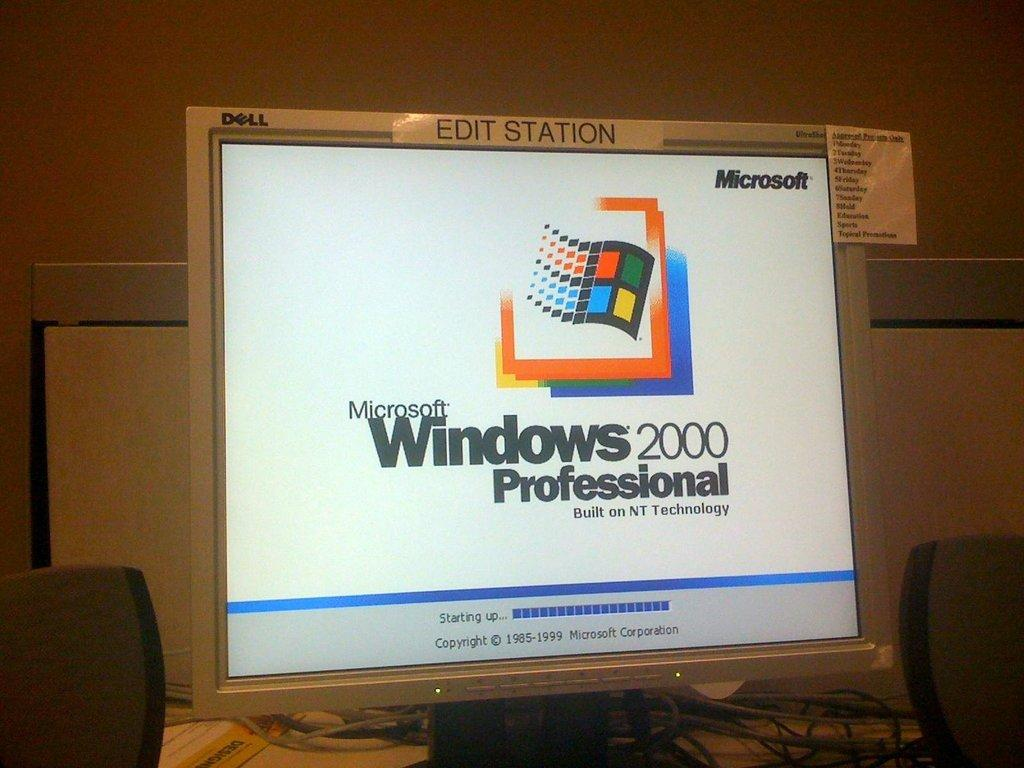What is: What electronic device can be seen in the image? There is a monitor in the image. What is visible on the monitor? Something is displayed on the monitor. What else can be seen in the image besides the monitor? There are wires visible in the image, and speakers are placed on the table. What is in the background of the image? There is a wall in the background of the image. What type of seed is being used to paste the screw onto the wall in the image? There is no seed, paste, or screw present in the image. 